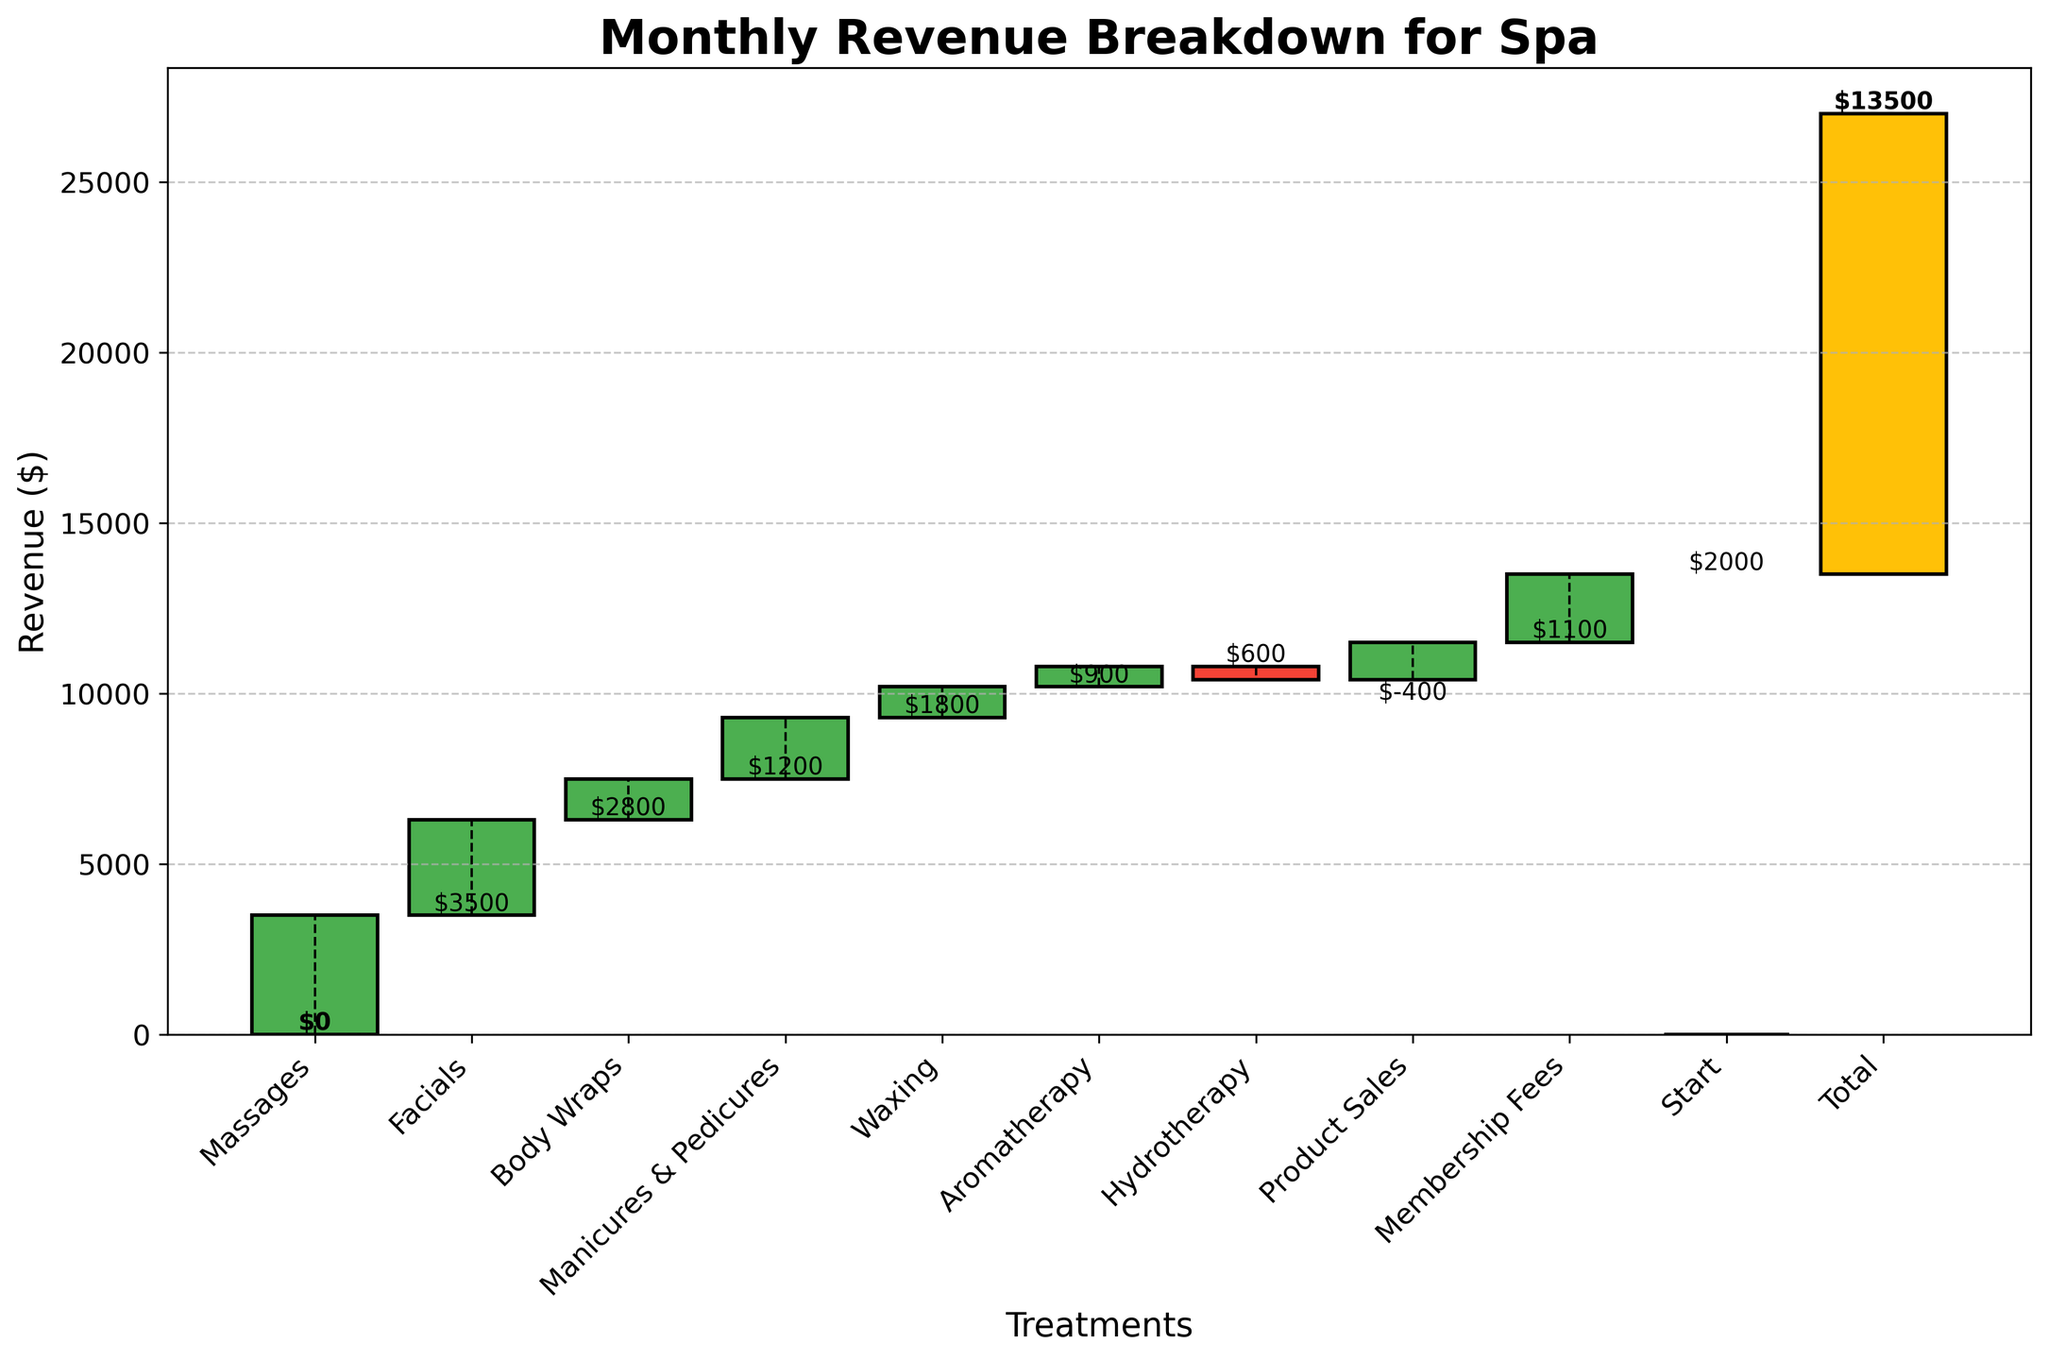What is the title of the figure? The title of the figure is displayed at the top and can be read directly.
Answer: Monthly Revenue Breakdown for Spa How much revenue did massages contribute? The value for massages is labeled on the figure, seen as $3500.
Answer: $3500 Which treatment had a decrease in revenue? The figure shows declining steps for negative values. Hydrotherapy is the only treatment that shows a decrease in revenue with -$400.
Answer: Hydrotherapy What is the total revenue for all treatments combined? The last bar labeled "Total" sums up all individual treatment revenues, shown as $13500.
Answer: $13500 What is the cumulative revenue after Body Wraps? Starting from zero, add the revenues of Massages ($3500), Facials ($2800), and Body Wraps ($1200). The cumulative sum is $3500 + $2800 + $1200 = $7500.
Answer: $7500 Which treatment contributed more revenue: Aromatherapy or Product Sales? The heights of the bars for Aromatherapy and Product Sales can be compared. Product Sales give $1100 and Aromatherapy $600.
Answer: Product Sales What is the revenue difference between Membership Fees and Facials? Membership Fees revenue is $2000 and Facials revenue is $2800. The difference is $2800 - $2000 = $800.
Answer: $800 How many treatments had a positive revenue? Counting the bars with positive heights shows the number of treatments as Massages, Facials, Body Wraps, Manicures & Pedicures, Waxing, Aromatherapy, Product Sales, and Membership Fees, which is 8 in total.
Answer: 8 What is the average revenue from Manicures & Pedicures, Waxing, and Aromatherapy? The revenues are $1800, $900, and $600 respectively. The average is calculated by (1800 + 900 + 600) / 3 = $1100.
Answer: $1100 What is the cumulative revenue up to Waxing? Starting from zero, add the revenues of Massages ($3500), Facials ($2800), Body Wraps ($1200), Manicures & Pedicures ($1800), and Waxing ($900). The cumulative sum is $3500 + $2800 + $1200 + $1800 + $900 = $10200.
Answer: $10200 